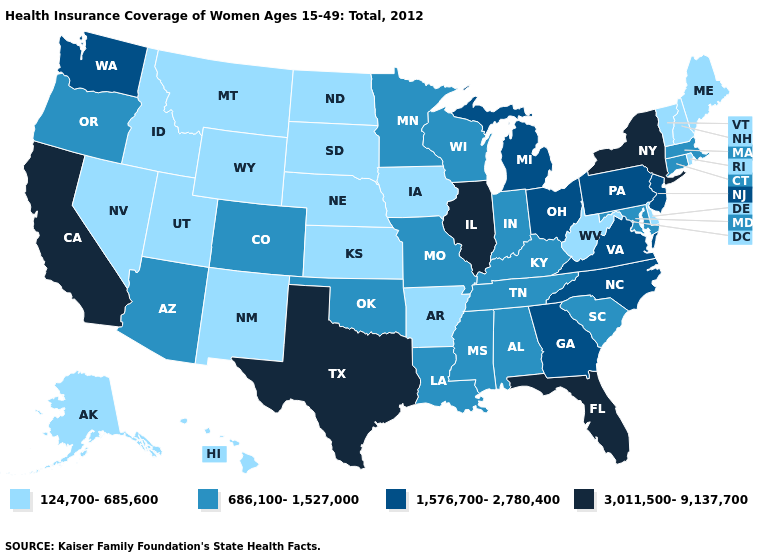What is the value of Kansas?
Keep it brief. 124,700-685,600. Name the states that have a value in the range 3,011,500-9,137,700?
Quick response, please. California, Florida, Illinois, New York, Texas. Does Rhode Island have a lower value than Arkansas?
Be succinct. No. What is the highest value in the USA?
Concise answer only. 3,011,500-9,137,700. What is the highest value in states that border New Mexico?
Write a very short answer. 3,011,500-9,137,700. Does Connecticut have the lowest value in the USA?
Short answer required. No. What is the value of North Carolina?
Be succinct. 1,576,700-2,780,400. Does North Dakota have the same value as Rhode Island?
Short answer required. Yes. Does Utah have the highest value in the West?
Quick response, please. No. What is the value of South Dakota?
Answer briefly. 124,700-685,600. What is the highest value in states that border Utah?
Quick response, please. 686,100-1,527,000. Does New Jersey have the highest value in the Northeast?
Concise answer only. No. Does New Hampshire have the lowest value in the Northeast?
Give a very brief answer. Yes. Among the states that border Colorado , which have the highest value?
Quick response, please. Arizona, Oklahoma. What is the value of Alaska?
Quick response, please. 124,700-685,600. 